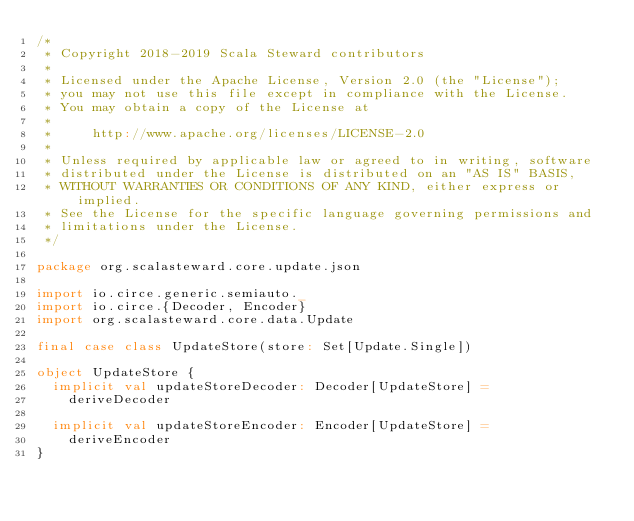<code> <loc_0><loc_0><loc_500><loc_500><_Scala_>/*
 * Copyright 2018-2019 Scala Steward contributors
 *
 * Licensed under the Apache License, Version 2.0 (the "License");
 * you may not use this file except in compliance with the License.
 * You may obtain a copy of the License at
 *
 *     http://www.apache.org/licenses/LICENSE-2.0
 *
 * Unless required by applicable law or agreed to in writing, software
 * distributed under the License is distributed on an "AS IS" BASIS,
 * WITHOUT WARRANTIES OR CONDITIONS OF ANY KIND, either express or implied.
 * See the License for the specific language governing permissions and
 * limitations under the License.
 */

package org.scalasteward.core.update.json

import io.circe.generic.semiauto._
import io.circe.{Decoder, Encoder}
import org.scalasteward.core.data.Update

final case class UpdateStore(store: Set[Update.Single])

object UpdateStore {
  implicit val updateStoreDecoder: Decoder[UpdateStore] =
    deriveDecoder

  implicit val updateStoreEncoder: Encoder[UpdateStore] =
    deriveEncoder
}
</code> 